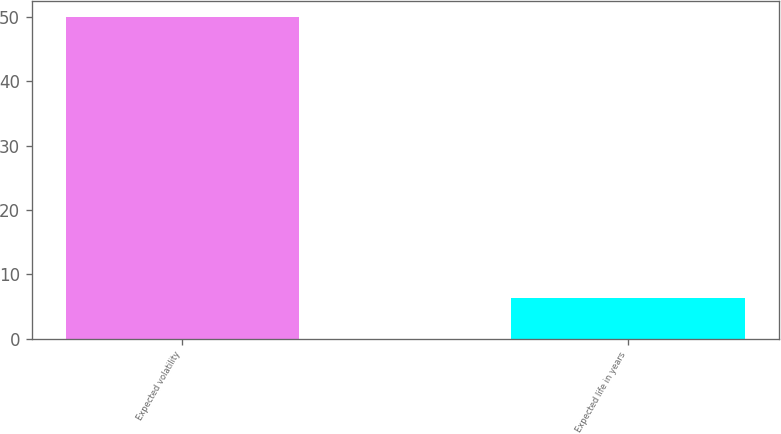Convert chart to OTSL. <chart><loc_0><loc_0><loc_500><loc_500><bar_chart><fcel>Expected volatility<fcel>Expected life in years<nl><fcel>50<fcel>6.25<nl></chart> 